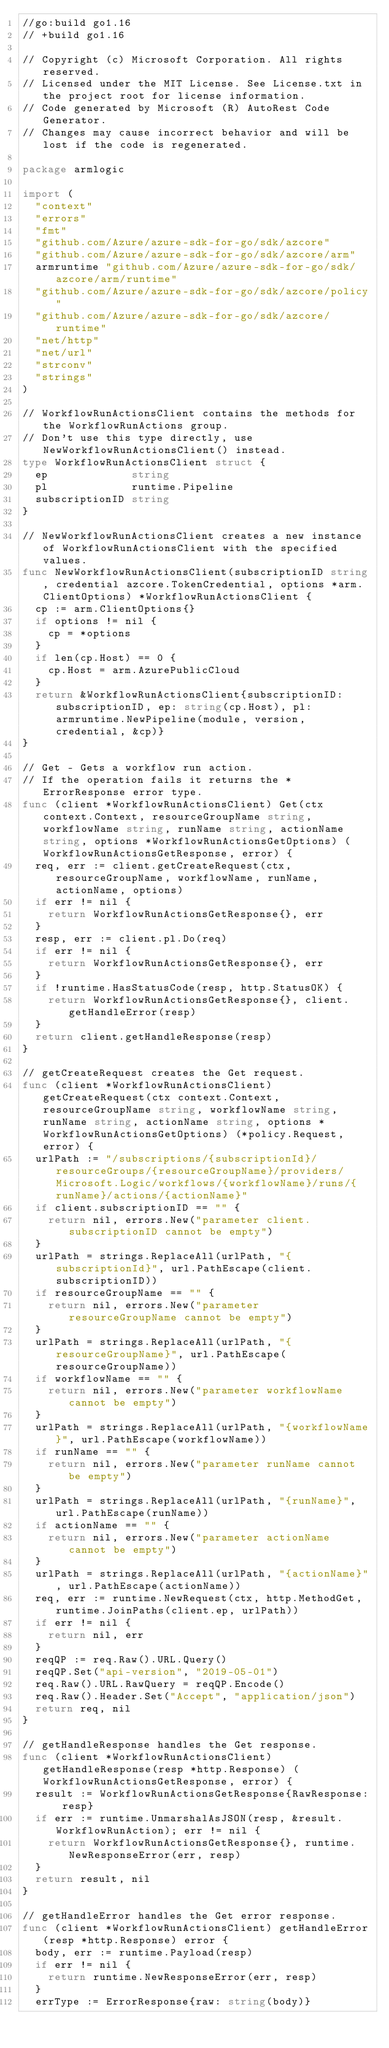<code> <loc_0><loc_0><loc_500><loc_500><_Go_>//go:build go1.16
// +build go1.16

// Copyright (c) Microsoft Corporation. All rights reserved.
// Licensed under the MIT License. See License.txt in the project root for license information.
// Code generated by Microsoft (R) AutoRest Code Generator.
// Changes may cause incorrect behavior and will be lost if the code is regenerated.

package armlogic

import (
	"context"
	"errors"
	"fmt"
	"github.com/Azure/azure-sdk-for-go/sdk/azcore"
	"github.com/Azure/azure-sdk-for-go/sdk/azcore/arm"
	armruntime "github.com/Azure/azure-sdk-for-go/sdk/azcore/arm/runtime"
	"github.com/Azure/azure-sdk-for-go/sdk/azcore/policy"
	"github.com/Azure/azure-sdk-for-go/sdk/azcore/runtime"
	"net/http"
	"net/url"
	"strconv"
	"strings"
)

// WorkflowRunActionsClient contains the methods for the WorkflowRunActions group.
// Don't use this type directly, use NewWorkflowRunActionsClient() instead.
type WorkflowRunActionsClient struct {
	ep             string
	pl             runtime.Pipeline
	subscriptionID string
}

// NewWorkflowRunActionsClient creates a new instance of WorkflowRunActionsClient with the specified values.
func NewWorkflowRunActionsClient(subscriptionID string, credential azcore.TokenCredential, options *arm.ClientOptions) *WorkflowRunActionsClient {
	cp := arm.ClientOptions{}
	if options != nil {
		cp = *options
	}
	if len(cp.Host) == 0 {
		cp.Host = arm.AzurePublicCloud
	}
	return &WorkflowRunActionsClient{subscriptionID: subscriptionID, ep: string(cp.Host), pl: armruntime.NewPipeline(module, version, credential, &cp)}
}

// Get - Gets a workflow run action.
// If the operation fails it returns the *ErrorResponse error type.
func (client *WorkflowRunActionsClient) Get(ctx context.Context, resourceGroupName string, workflowName string, runName string, actionName string, options *WorkflowRunActionsGetOptions) (WorkflowRunActionsGetResponse, error) {
	req, err := client.getCreateRequest(ctx, resourceGroupName, workflowName, runName, actionName, options)
	if err != nil {
		return WorkflowRunActionsGetResponse{}, err
	}
	resp, err := client.pl.Do(req)
	if err != nil {
		return WorkflowRunActionsGetResponse{}, err
	}
	if !runtime.HasStatusCode(resp, http.StatusOK) {
		return WorkflowRunActionsGetResponse{}, client.getHandleError(resp)
	}
	return client.getHandleResponse(resp)
}

// getCreateRequest creates the Get request.
func (client *WorkflowRunActionsClient) getCreateRequest(ctx context.Context, resourceGroupName string, workflowName string, runName string, actionName string, options *WorkflowRunActionsGetOptions) (*policy.Request, error) {
	urlPath := "/subscriptions/{subscriptionId}/resourceGroups/{resourceGroupName}/providers/Microsoft.Logic/workflows/{workflowName}/runs/{runName}/actions/{actionName}"
	if client.subscriptionID == "" {
		return nil, errors.New("parameter client.subscriptionID cannot be empty")
	}
	urlPath = strings.ReplaceAll(urlPath, "{subscriptionId}", url.PathEscape(client.subscriptionID))
	if resourceGroupName == "" {
		return nil, errors.New("parameter resourceGroupName cannot be empty")
	}
	urlPath = strings.ReplaceAll(urlPath, "{resourceGroupName}", url.PathEscape(resourceGroupName))
	if workflowName == "" {
		return nil, errors.New("parameter workflowName cannot be empty")
	}
	urlPath = strings.ReplaceAll(urlPath, "{workflowName}", url.PathEscape(workflowName))
	if runName == "" {
		return nil, errors.New("parameter runName cannot be empty")
	}
	urlPath = strings.ReplaceAll(urlPath, "{runName}", url.PathEscape(runName))
	if actionName == "" {
		return nil, errors.New("parameter actionName cannot be empty")
	}
	urlPath = strings.ReplaceAll(urlPath, "{actionName}", url.PathEscape(actionName))
	req, err := runtime.NewRequest(ctx, http.MethodGet, runtime.JoinPaths(client.ep, urlPath))
	if err != nil {
		return nil, err
	}
	reqQP := req.Raw().URL.Query()
	reqQP.Set("api-version", "2019-05-01")
	req.Raw().URL.RawQuery = reqQP.Encode()
	req.Raw().Header.Set("Accept", "application/json")
	return req, nil
}

// getHandleResponse handles the Get response.
func (client *WorkflowRunActionsClient) getHandleResponse(resp *http.Response) (WorkflowRunActionsGetResponse, error) {
	result := WorkflowRunActionsGetResponse{RawResponse: resp}
	if err := runtime.UnmarshalAsJSON(resp, &result.WorkflowRunAction); err != nil {
		return WorkflowRunActionsGetResponse{}, runtime.NewResponseError(err, resp)
	}
	return result, nil
}

// getHandleError handles the Get error response.
func (client *WorkflowRunActionsClient) getHandleError(resp *http.Response) error {
	body, err := runtime.Payload(resp)
	if err != nil {
		return runtime.NewResponseError(err, resp)
	}
	errType := ErrorResponse{raw: string(body)}</code> 